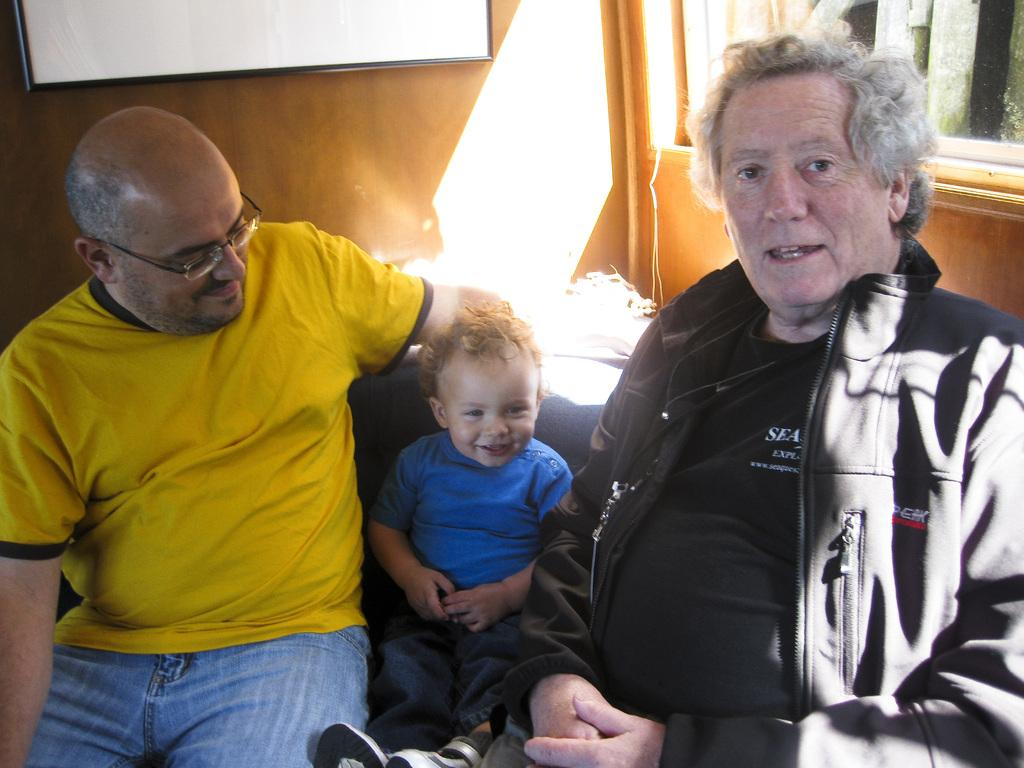Where was the image taken? The image was taken indoors. What can be seen in the background of the image? There is a wall with a window in the background. What is hanging on the wall in the image? There is a picture frame on the wall. What are the people in the image doing? Two men and a kid are sitting on a couch in the middle of the image. What type of hair can be seen on the sidewalk in the image? There is no sidewalk or hair present in the image; it is taken indoors and features a couch with people sitting on it. 